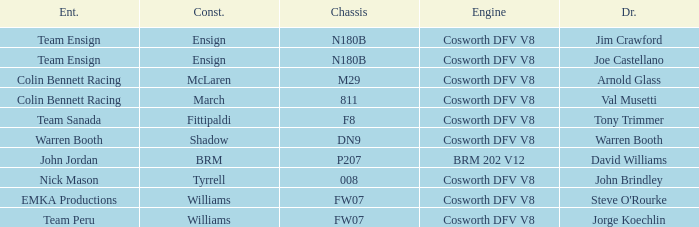Who built the Jim Crawford car? Ensign. Would you mind parsing the complete table? {'header': ['Ent.', 'Const.', 'Chassis', 'Engine', 'Dr.'], 'rows': [['Team Ensign', 'Ensign', 'N180B', 'Cosworth DFV V8', 'Jim Crawford'], ['Team Ensign', 'Ensign', 'N180B', 'Cosworth DFV V8', 'Joe Castellano'], ['Colin Bennett Racing', 'McLaren', 'M29', 'Cosworth DFV V8', 'Arnold Glass'], ['Colin Bennett Racing', 'March', '811', 'Cosworth DFV V8', 'Val Musetti'], ['Team Sanada', 'Fittipaldi', 'F8', 'Cosworth DFV V8', 'Tony Trimmer'], ['Warren Booth', 'Shadow', 'DN9', 'Cosworth DFV V8', 'Warren Booth'], ['John Jordan', 'BRM', 'P207', 'BRM 202 V12', 'David Williams'], ['Nick Mason', 'Tyrrell', '008', 'Cosworth DFV V8', 'John Brindley'], ['EMKA Productions', 'Williams', 'FW07', 'Cosworth DFV V8', "Steve O'Rourke"], ['Team Peru', 'Williams', 'FW07', 'Cosworth DFV V8', 'Jorge Koechlin']]} 